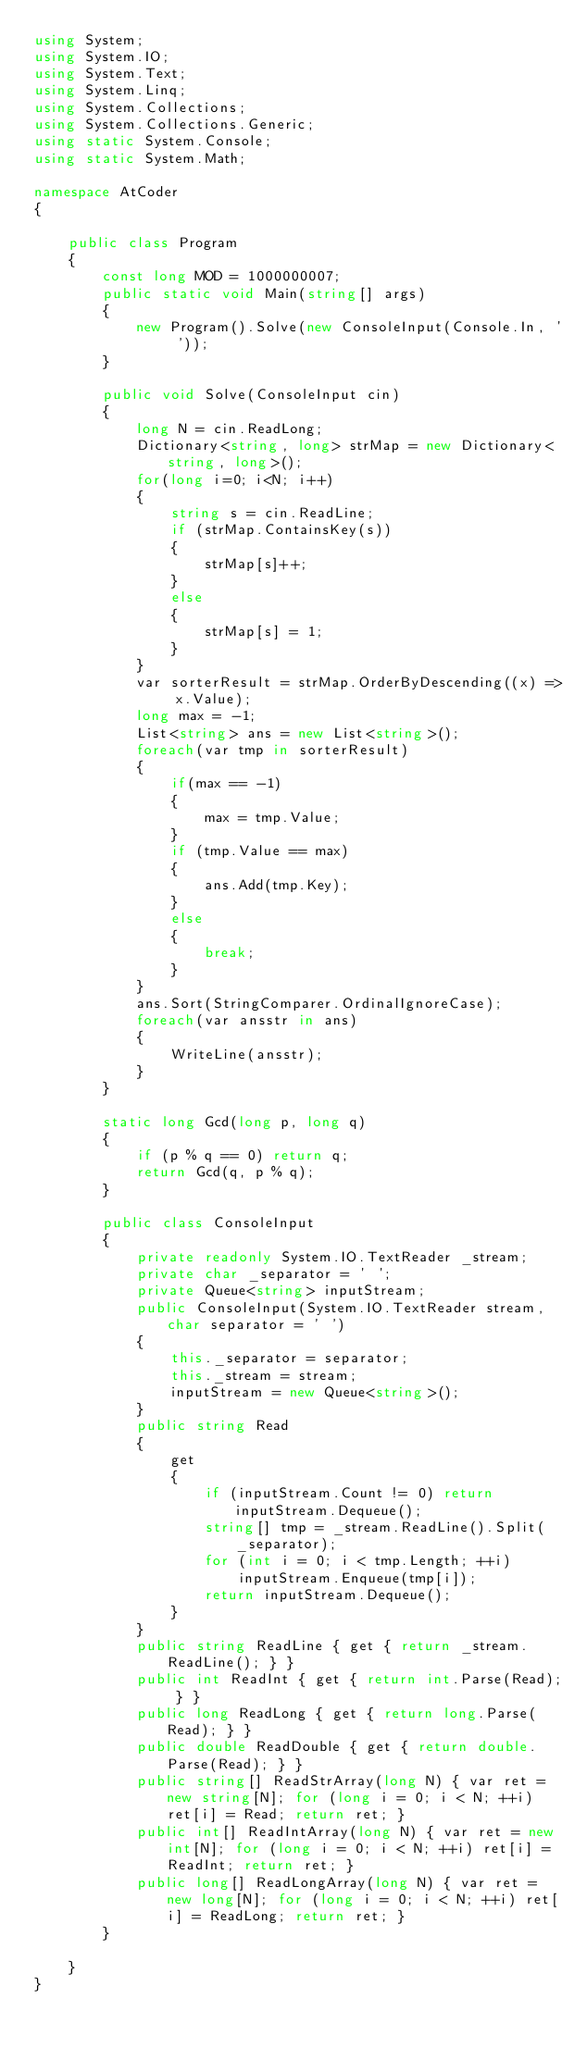<code> <loc_0><loc_0><loc_500><loc_500><_C#_>using System;
using System.IO;
using System.Text;
using System.Linq;
using System.Collections;
using System.Collections.Generic;
using static System.Console;
using static System.Math;

namespace AtCoder
{

    public class Program
    {
        const long MOD = 1000000007;
        public static void Main(string[] args)
        {
            new Program().Solve(new ConsoleInput(Console.In, ' '));
        }

        public void Solve(ConsoleInput cin)
        {
            long N = cin.ReadLong;
            Dictionary<string, long> strMap = new Dictionary<string, long>();
            for(long i=0; i<N; i++)
            {
                string s = cin.ReadLine;
                if (strMap.ContainsKey(s))
                {
                    strMap[s]++;
                }
                else
                {
                    strMap[s] = 1;
                }
            }
            var sorterResult = strMap.OrderByDescending((x) => x.Value);
            long max = -1;
            List<string> ans = new List<string>();
            foreach(var tmp in sorterResult)
            {
                if(max == -1)
                {
                    max = tmp.Value;
                }
                if (tmp.Value == max)
                {
                    ans.Add(tmp.Key);
                }
                else
                {
                    break;
                }
            }
            ans.Sort(StringComparer.OrdinalIgnoreCase);
            foreach(var ansstr in ans)
            {
                WriteLine(ansstr);
            }
        }

        static long Gcd(long p, long q)
        {
            if (p % q == 0) return q;
            return Gcd(q, p % q);
        }

        public class ConsoleInput
        {
            private readonly System.IO.TextReader _stream;
            private char _separator = ' ';
            private Queue<string> inputStream;
            public ConsoleInput(System.IO.TextReader stream, char separator = ' ')
            {
                this._separator = separator;
                this._stream = stream;
                inputStream = new Queue<string>();
            }
            public string Read
            {
                get
                {
                    if (inputStream.Count != 0) return inputStream.Dequeue();
                    string[] tmp = _stream.ReadLine().Split(_separator);
                    for (int i = 0; i < tmp.Length; ++i)
                        inputStream.Enqueue(tmp[i]);
                    return inputStream.Dequeue();
                }
            }
            public string ReadLine { get { return _stream.ReadLine(); } }
            public int ReadInt { get { return int.Parse(Read); } }
            public long ReadLong { get { return long.Parse(Read); } }
            public double ReadDouble { get { return double.Parse(Read); } }
            public string[] ReadStrArray(long N) { var ret = new string[N]; for (long i = 0; i < N; ++i) ret[i] = Read; return ret; }
            public int[] ReadIntArray(long N) { var ret = new int[N]; for (long i = 0; i < N; ++i) ret[i] = ReadInt; return ret; }
            public long[] ReadLongArray(long N) { var ret = new long[N]; for (long i = 0; i < N; ++i) ret[i] = ReadLong; return ret; }
        }

    }
}</code> 